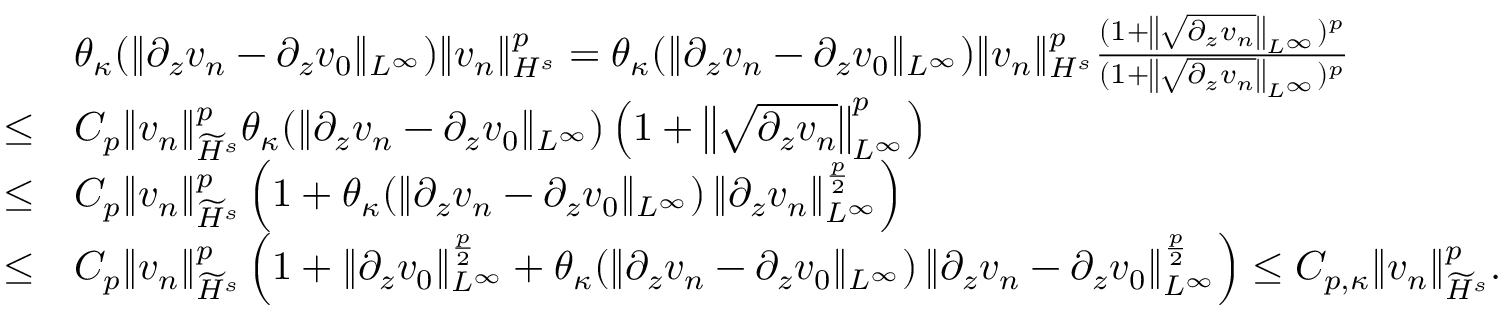Convert formula to latex. <formula><loc_0><loc_0><loc_500><loc_500>\begin{array} { r l } & { \theta _ { \kappa } ( \| \partial _ { z } v _ { n } - \partial _ { z } v _ { 0 } \| _ { L ^ { \infty } } ) \| v _ { n } \| _ { H ^ { s } } ^ { p } = \theta _ { \kappa } ( \| \partial _ { z } v _ { n } - \partial _ { z } v _ { 0 } \| _ { L ^ { \infty } } ) \| v _ { n } \| _ { H ^ { s } } ^ { p } \frac { ( 1 + \left \| \sqrt { \partial _ { z } v _ { n } } \right \| _ { L ^ { \infty } } ) ^ { p } } { ( 1 + \left \| \sqrt { \partial _ { z } v _ { n } } \right \| _ { L ^ { \infty } } ) ^ { p } } } \\ { \leq } & { C _ { p } \| v _ { n } \| _ { \widetilde { H } ^ { s } } ^ { p } \theta _ { \kappa } ( \| \partial _ { z } v _ { n } - \partial _ { z } v _ { 0 } \| _ { L ^ { \infty } } ) \left ( 1 + \left \| \sqrt { \partial _ { z } v _ { n } } \right \| _ { L ^ { \infty } } ^ { p } \right ) } \\ { \leq } & { C _ { p } \| v _ { n } \| _ { \widetilde { H } ^ { s } } ^ { p } \left ( 1 + \theta _ { \kappa } ( \| \partial _ { z } v _ { n } - \partial _ { z } v _ { 0 } \| _ { L ^ { \infty } } ) \left \| \partial _ { z } v _ { n } \right \| _ { L ^ { \infty } } ^ { \frac { p } { 2 } } \right ) } \\ { \leq } & { C _ { p } \| v _ { n } \| _ { \widetilde { H } ^ { s } } ^ { p } \left ( 1 + \| \partial _ { z } v _ { 0 } \| _ { L ^ { \infty } } ^ { \frac { p } { 2 } } + \theta _ { \kappa } ( \| \partial _ { z } v _ { n } - \partial _ { z } v _ { 0 } \| _ { L ^ { \infty } } ) \left \| \partial _ { z } v _ { n } - \partial _ { z } v _ { 0 } \right \| _ { L ^ { \infty } } ^ { \frac { p } { 2 } } \right ) \leq C _ { p , \kappa } \| v _ { n } \| _ { \widetilde { H } ^ { s } } ^ { p } . } \end{array}</formula> 